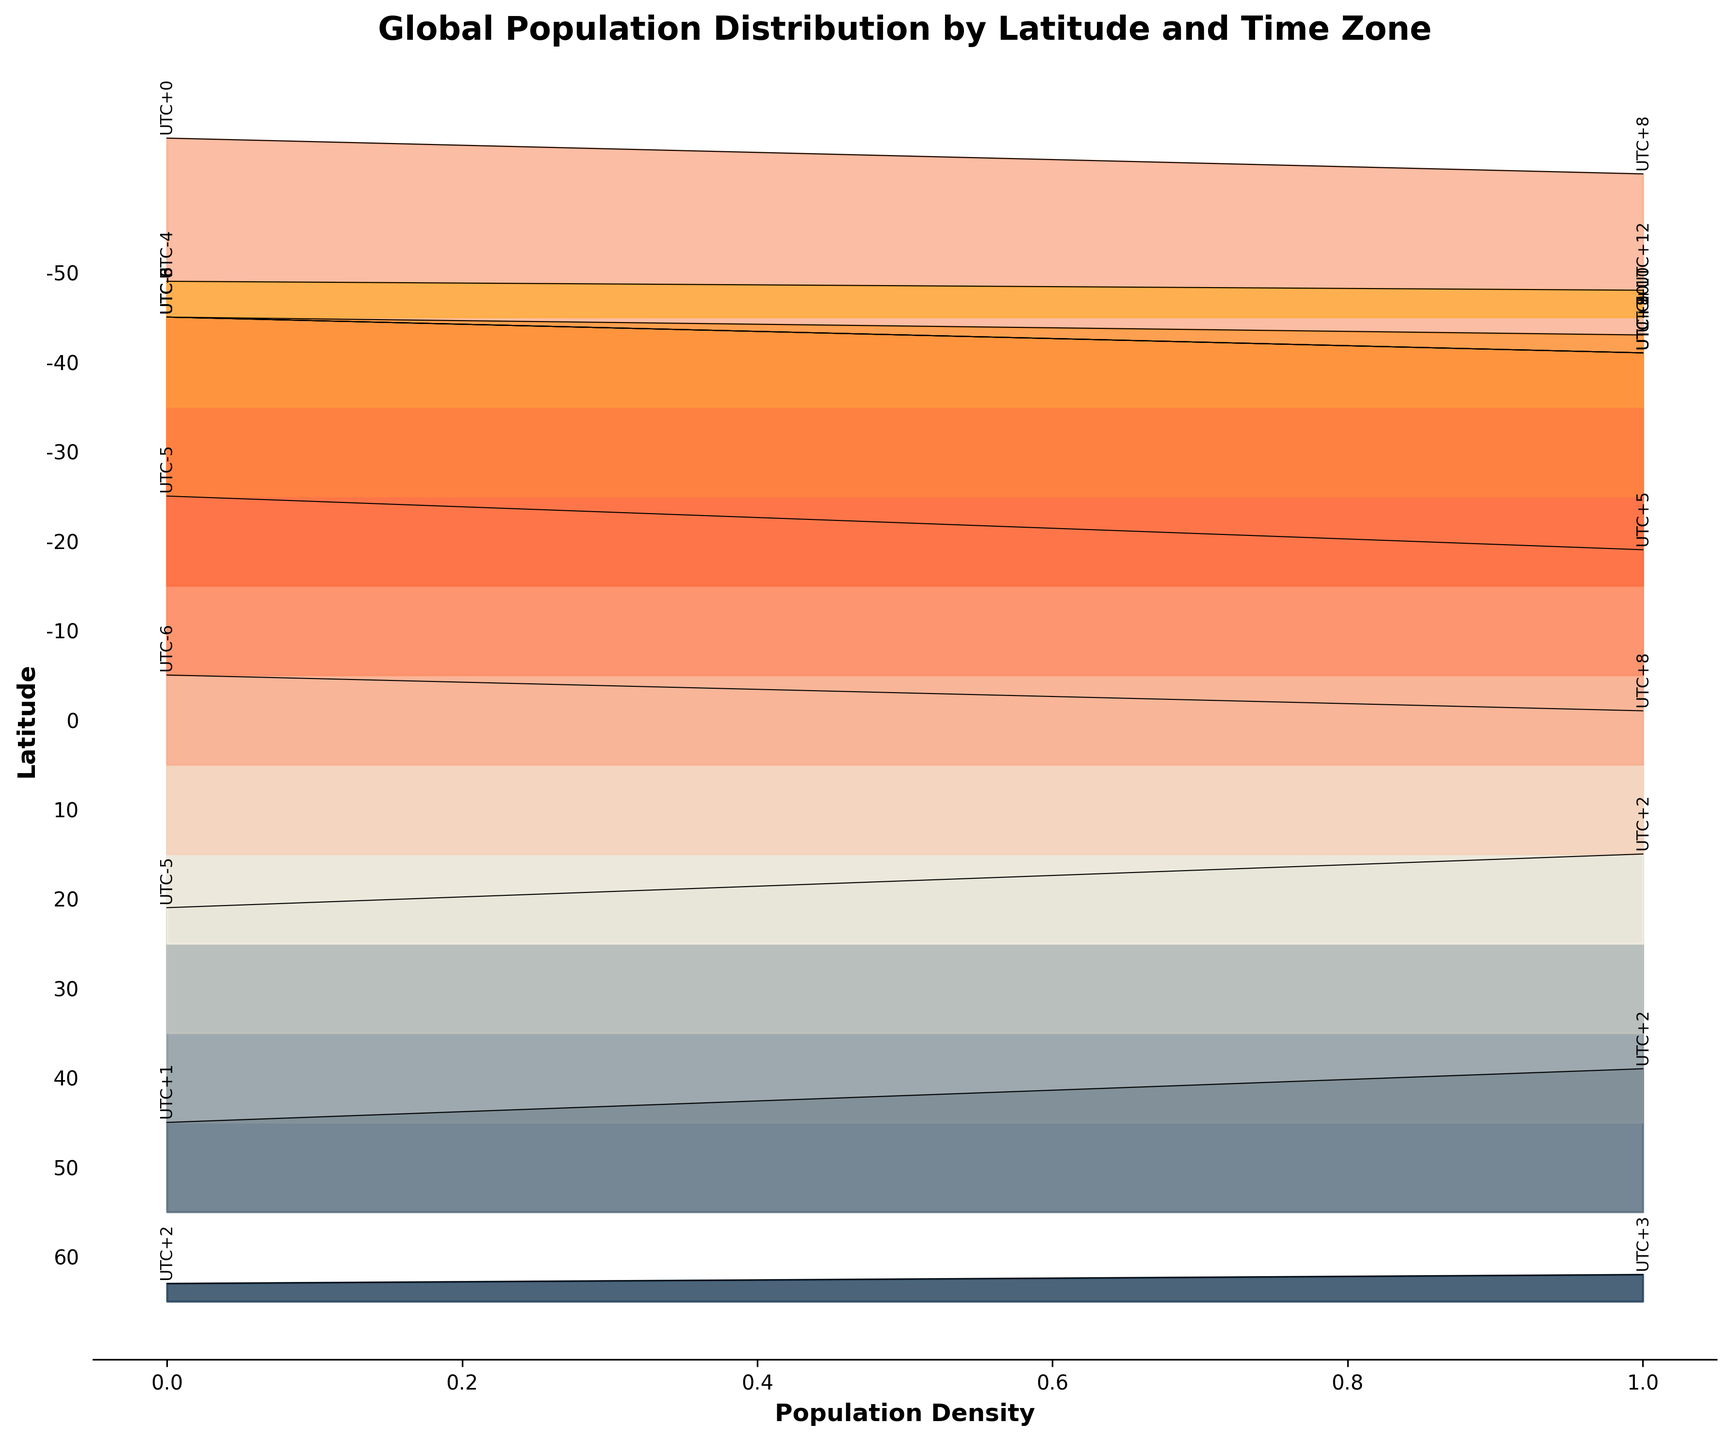What is the title of the plot? The title is typically found at the top of the figure. In this case, it reads, "Global Population Distribution by Latitude and Time Zone."
Answer: Global Population Distribution by Latitude and Time Zone What does the x-axis represent? The x-axis label indicates what is represented along this axis. In this plot, it is labeled "Population Density."
Answer: Population Density How many unique latitude lines are displayed in the plot? By counting the labels on the y-axis (ensuring no duplicates), we can determine the number of unique latitudes. There are 12 unique latitude lines displayed.
Answer: 12 Which latitude has the highest population density, and what is its corresponding value? By comparing the filled areas along the x-axis, we can identify the line that extends farthest. The latitude at 0 degrees has the highest density, with a value of 350.
Answer: 0 degrees, 350 Which time zone has the highest associated population density, and what is that value? By examining the annotations next to the highest population density, we see that UTC+0 corresponds to the highest density at 0 degrees latitude with a value of 350.
Answer: UTC+0, 350 Compare the population densities at latitude 10 for time zones UTC-6 and UTC+7. Which one is higher? Check the annotated population densities for both time zones at latitude 10. UTC-6 has a density of 300, while UTC+7 has a density of 280. Therefore, UTC-6 is higher.
Answer: UTC-6 What is the average population density for latitude 30? Sum up the population densities for both time zones at latitude 30 (200 and 180), then divide by the number of data points (2). (200 + 180) / 2 = 190.
Answer: 190 Identify the latitude and corresponding time zone with the lowest population density. Look for the smallest filled area along the x-axis. The lowest density is at latitude -50 degrees with a value of 15 in the UTC+12 time zone.
Answer: -50, UTC+12, 15 Is the population density higher at latitude 50 for UTC+1 or UTC+2? Compare the heights of the filled areas for latitudes 50 at the respective time zones. UTC+2 has a higher density (80) compared to UTC+1 (50).
Answer: UTC+2 At latitude -10, how do population densities of time zones UTC-3 and UTC+10 compare? Check the annotated densities for these time zones at -10 latitude. UTC-3 has a density of 200, and UTC+10 has 180. UTC-3 is higher.
Answer: UTC-3 